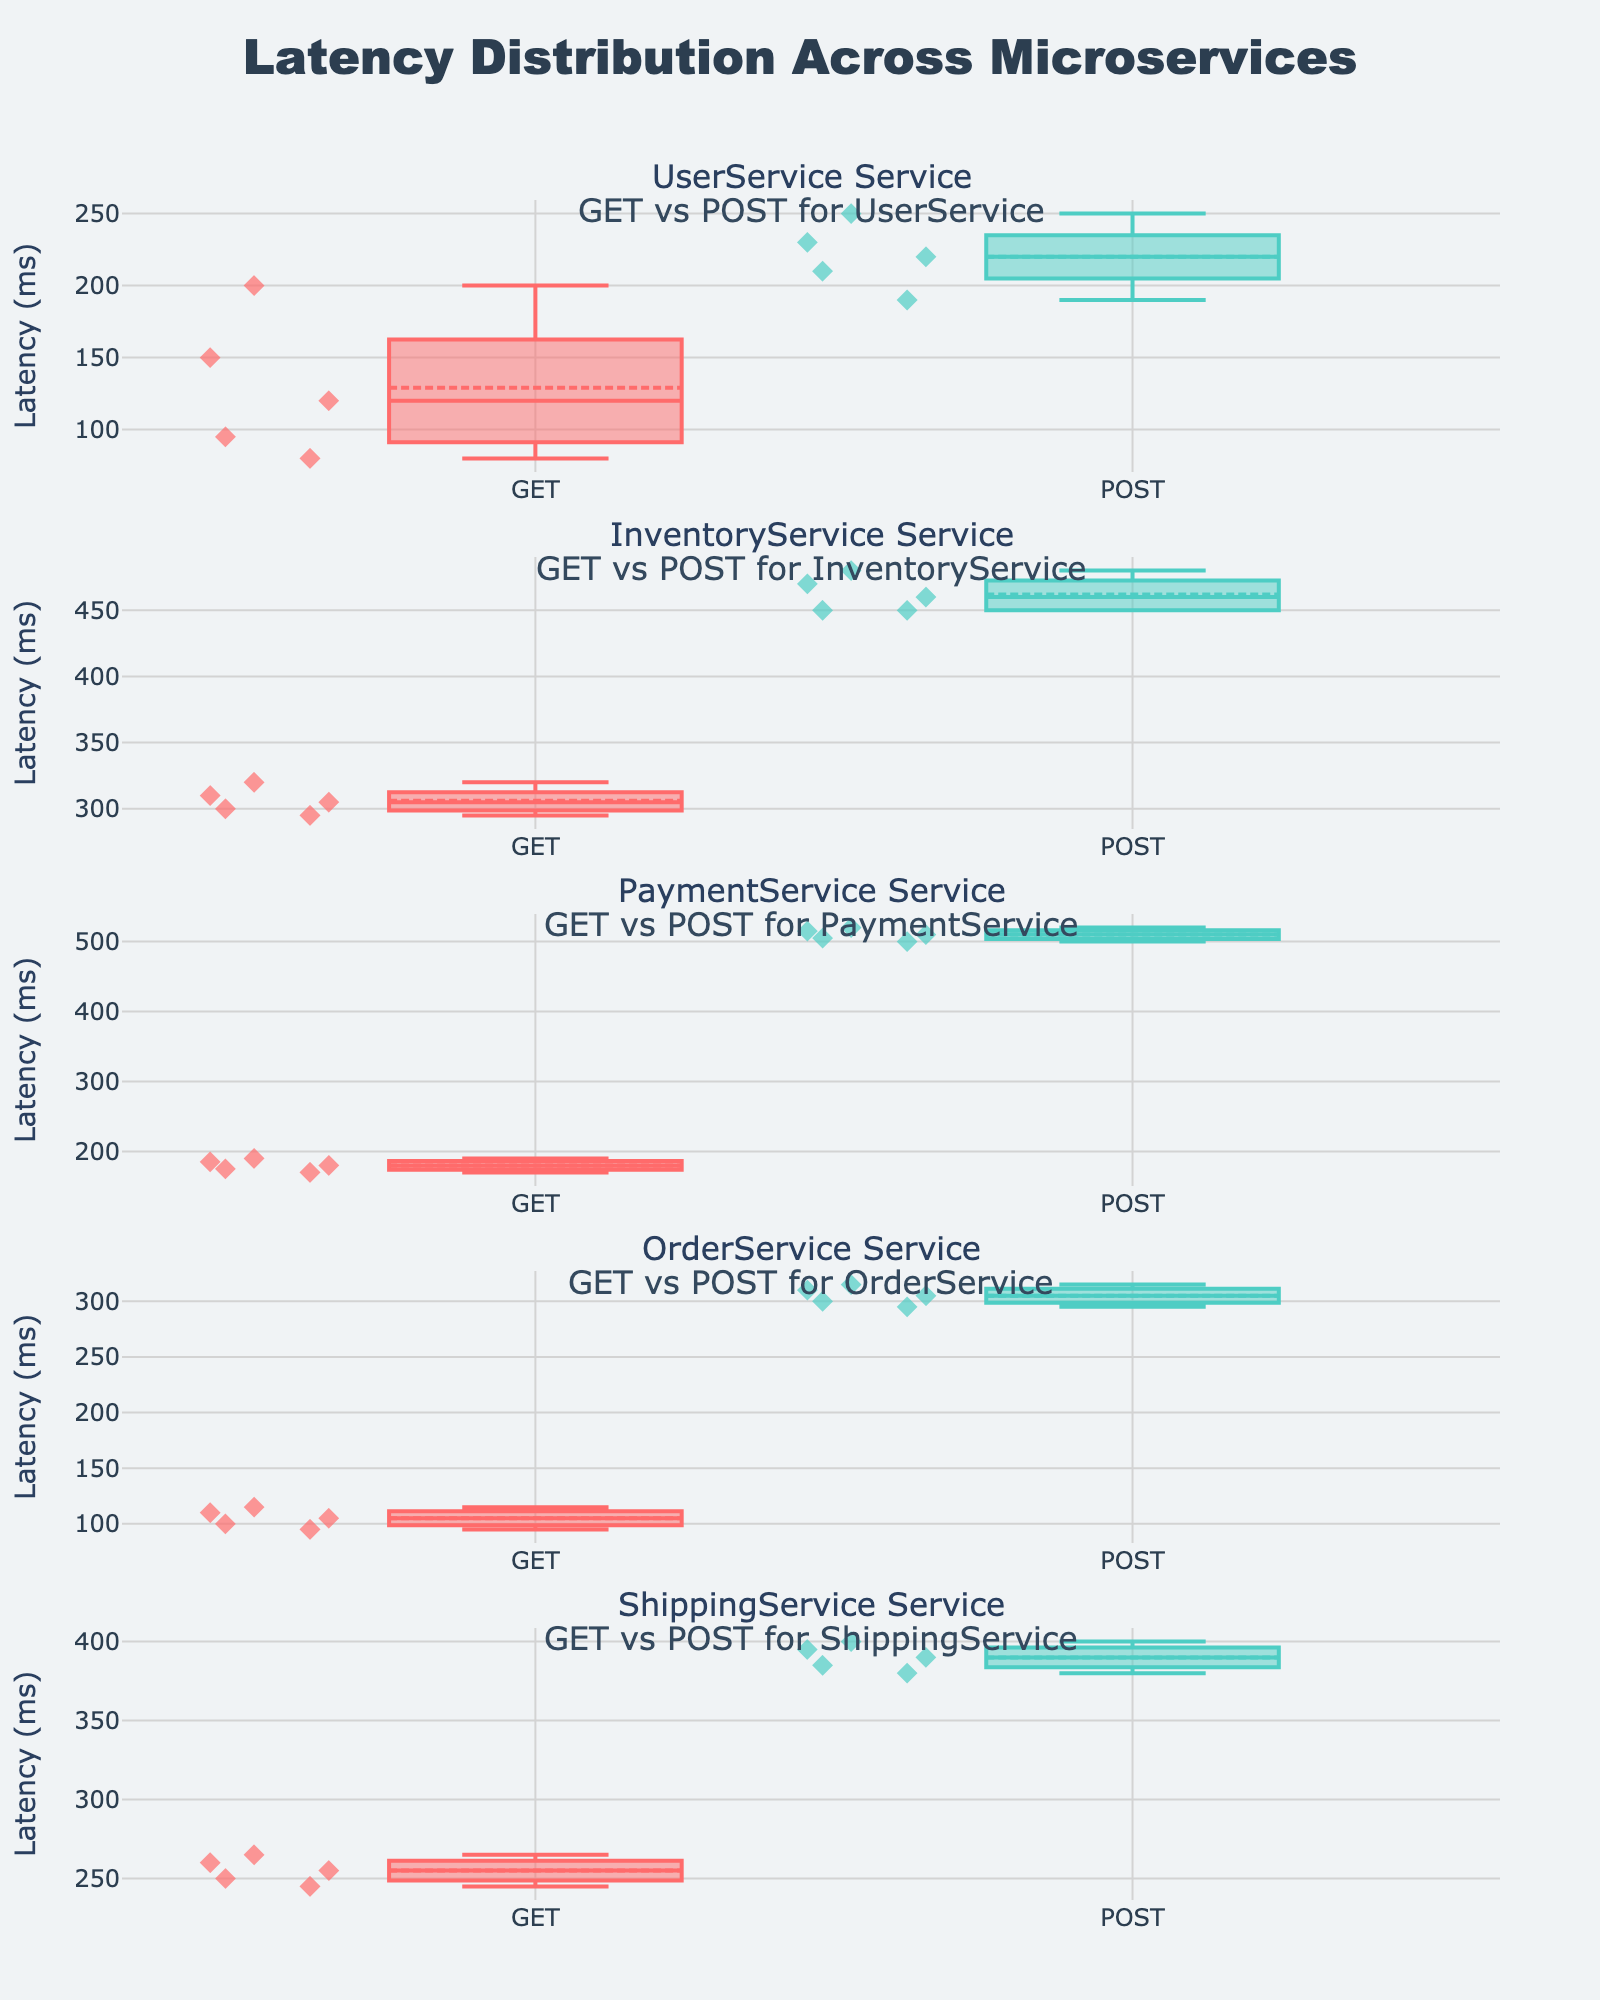What is the title of the plot? The title is located at the top of the figure and describes the overall theme of the plot.
Answer: Latency Distribution Across Microservices Which request type has the lowest median latency in the UserService? The box plot for UserService needs to be examined, specifically comparing the median lines for GET and POST request types.
Answer: GET What is the range of latencies for POST requests in the InventoryService? You need to observe the box plot for POST requests in the InventoryService and look at the lowest and highest points (whiskers) to determine the range.
Answer: 450-480 ms How do GET request latencies in PaymentService compare to POST request latencies? By comparing the medians and the spread of the box plots for GET and POST requests in the PaymentService, you can see if one is generally higher or lower than the other.
Answer: GET requests have lower latencies than POST requests Which microservice has the most variability in POST request latencies? You should look at the spread (interquartile range) of the POST request box plots in the subplots for all services to find the one with the greatest variability.
Answer: PaymentService What is the general latency trend for GET requests across all services? By examining and comparing the median lines in the box plots for GET requests across all services, you can identify the general trend or pattern of latencies.
Answer: Increases from UserService to ShippingService Which service has the smallest difference between GET and POST median latencies? Compare the median lines of GET and POST requests within each service to find the service where the difference is the smallest.
Answer: PaymentService How does the dispersion of latencies in POST requests for the OrderService compare to that of the ShippingService? Look at the length of the boxes and the range (whiskers) for POST requests in both OrderService and ShippingService and compare their dispersion.
Answer: OrderService has less dispersion 